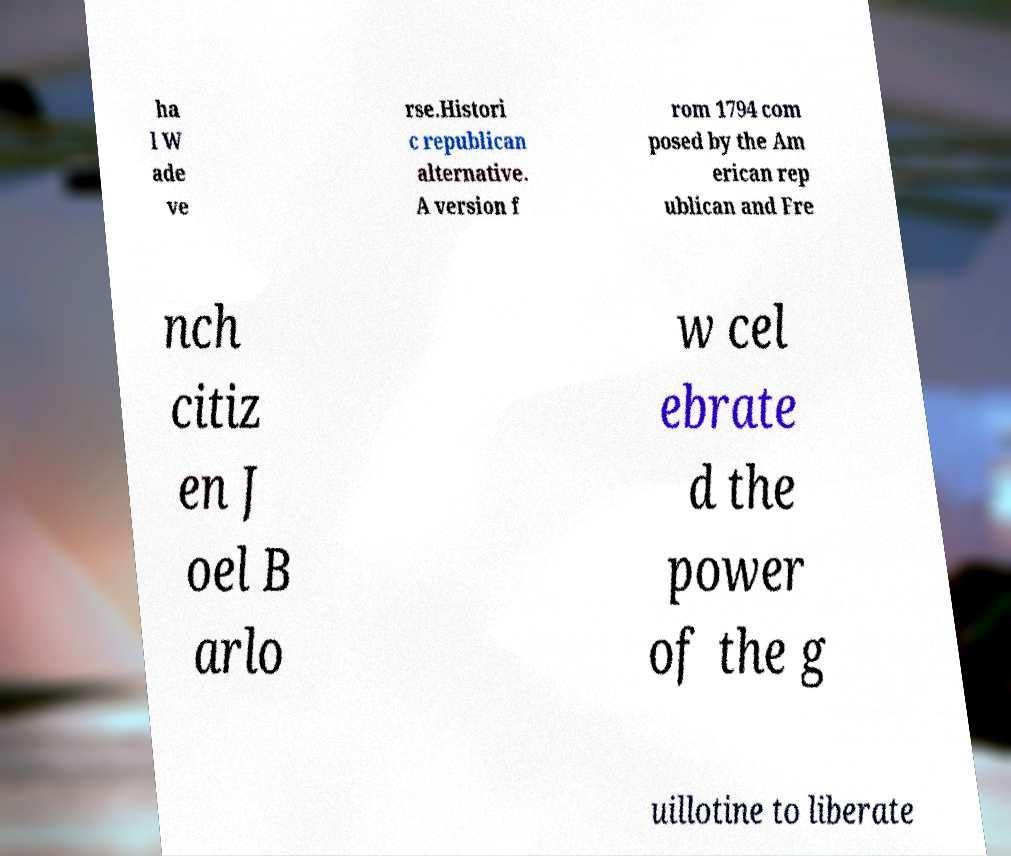Could you assist in decoding the text presented in this image and type it out clearly? ha l W ade ve rse.Histori c republican alternative. A version f rom 1794 com posed by the Am erican rep ublican and Fre nch citiz en J oel B arlo w cel ebrate d the power of the g uillotine to liberate 